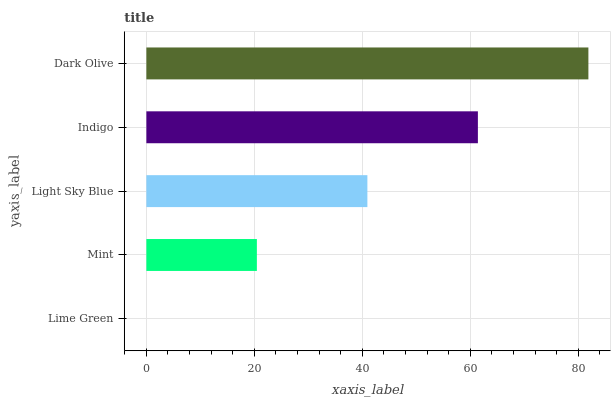Is Lime Green the minimum?
Answer yes or no. Yes. Is Dark Olive the maximum?
Answer yes or no. Yes. Is Mint the minimum?
Answer yes or no. No. Is Mint the maximum?
Answer yes or no. No. Is Mint greater than Lime Green?
Answer yes or no. Yes. Is Lime Green less than Mint?
Answer yes or no. Yes. Is Lime Green greater than Mint?
Answer yes or no. No. Is Mint less than Lime Green?
Answer yes or no. No. Is Light Sky Blue the high median?
Answer yes or no. Yes. Is Light Sky Blue the low median?
Answer yes or no. Yes. Is Indigo the high median?
Answer yes or no. No. Is Mint the low median?
Answer yes or no. No. 